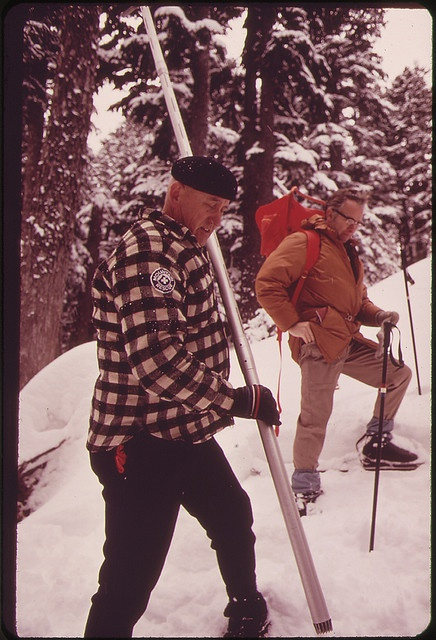Describe the objects in this image and their specific colors. I can see people in black, maroon, brown, and purple tones, people in black, brown, and maroon tones, backpack in black, brown, maroon, and salmon tones, and skis in black, brown, maroon, and pink tones in this image. 